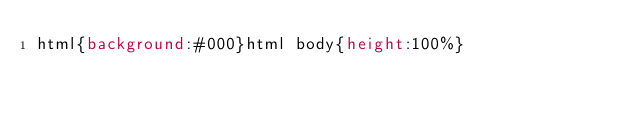<code> <loc_0><loc_0><loc_500><loc_500><_CSS_>html{background:#000}html body{height:100%}</code> 